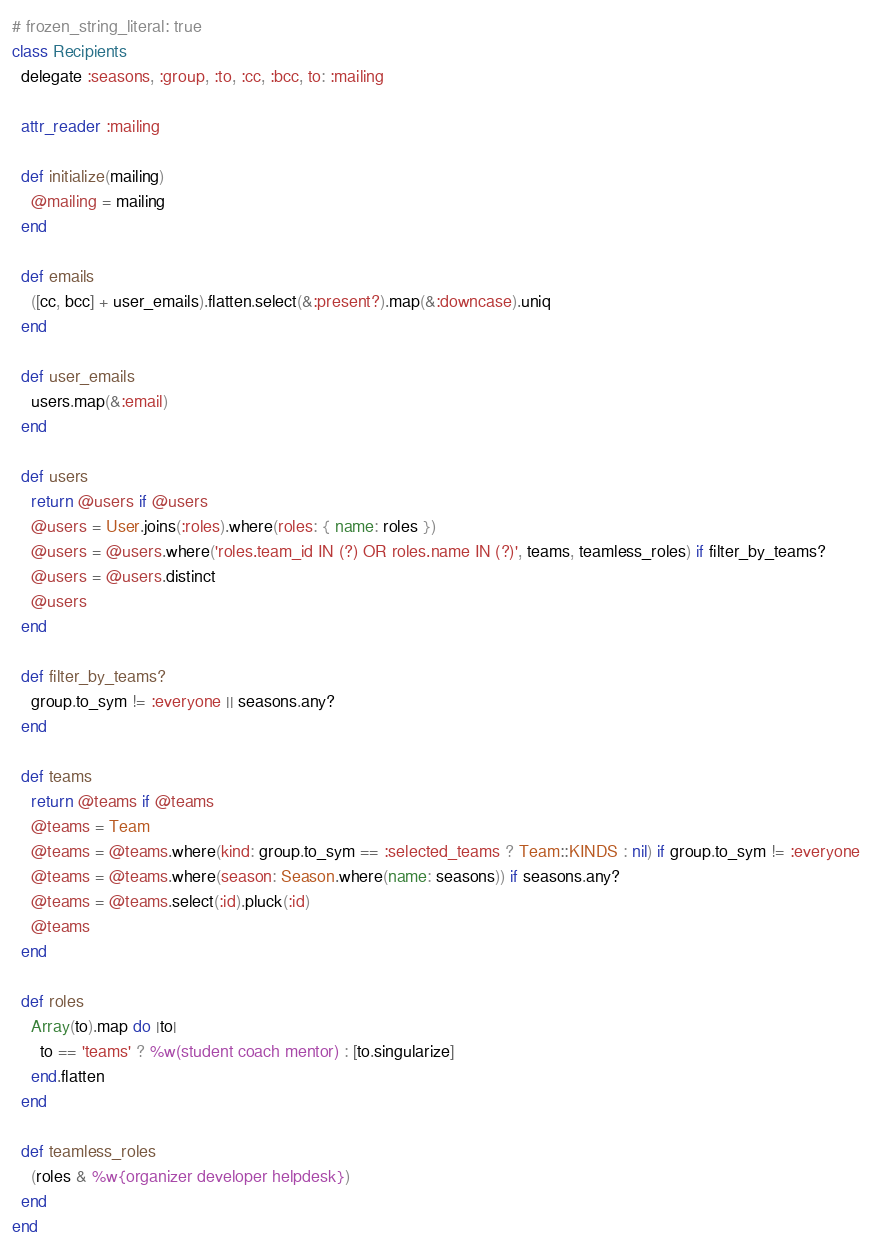<code> <loc_0><loc_0><loc_500><loc_500><_Ruby_># frozen_string_literal: true
class Recipients
  delegate :seasons, :group, :to, :cc, :bcc, to: :mailing

  attr_reader :mailing

  def initialize(mailing)
    @mailing = mailing
  end

  def emails
    ([cc, bcc] + user_emails).flatten.select(&:present?).map(&:downcase).uniq
  end

  def user_emails
    users.map(&:email)
  end

  def users
    return @users if @users
    @users = User.joins(:roles).where(roles: { name: roles })
    @users = @users.where('roles.team_id IN (?) OR roles.name IN (?)', teams, teamless_roles) if filter_by_teams?
    @users = @users.distinct
    @users
  end

  def filter_by_teams?
    group.to_sym != :everyone || seasons.any?
  end

  def teams
    return @teams if @teams
    @teams = Team
    @teams = @teams.where(kind: group.to_sym == :selected_teams ? Team::KINDS : nil) if group.to_sym != :everyone
    @teams = @teams.where(season: Season.where(name: seasons)) if seasons.any?
    @teams = @teams.select(:id).pluck(:id)
    @teams
  end

  def roles
    Array(to).map do |to|
      to == 'teams' ? %w(student coach mentor) : [to.singularize]
    end.flatten
  end

  def teamless_roles
    (roles & %w{organizer developer helpdesk})
  end
end
</code> 